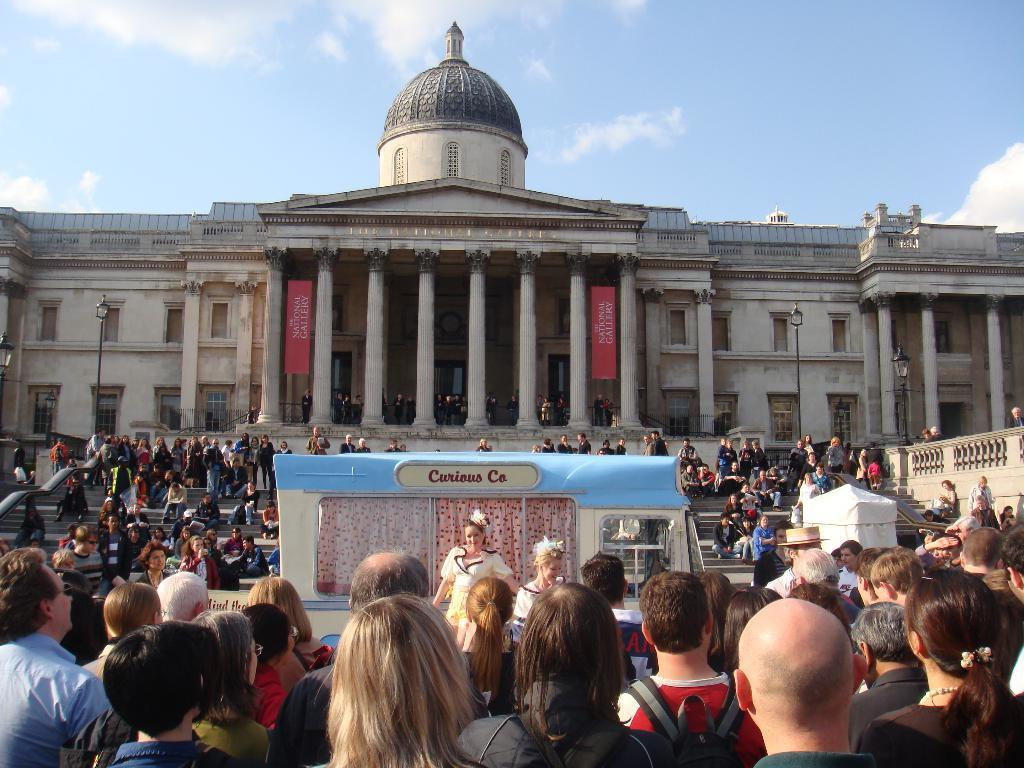What is the main structure in the center of the image? There is a building in the center of the image. What type of vehicle can be seen at the bottom of the image? There is a vehicle at the bottom of the image. Can you describe the people in the image? There is a crowd visible in the image. What is visible in the background of the image? There is sky in the background of the image. What objects are present in the image that are not the building, vehicle, or crowd? A: There are poles in the image. What type of linen is being used to cover the pig in the image? There is no pig or linen present in the image; it features a building, a vehicle, a crowd, sky, and poles. 